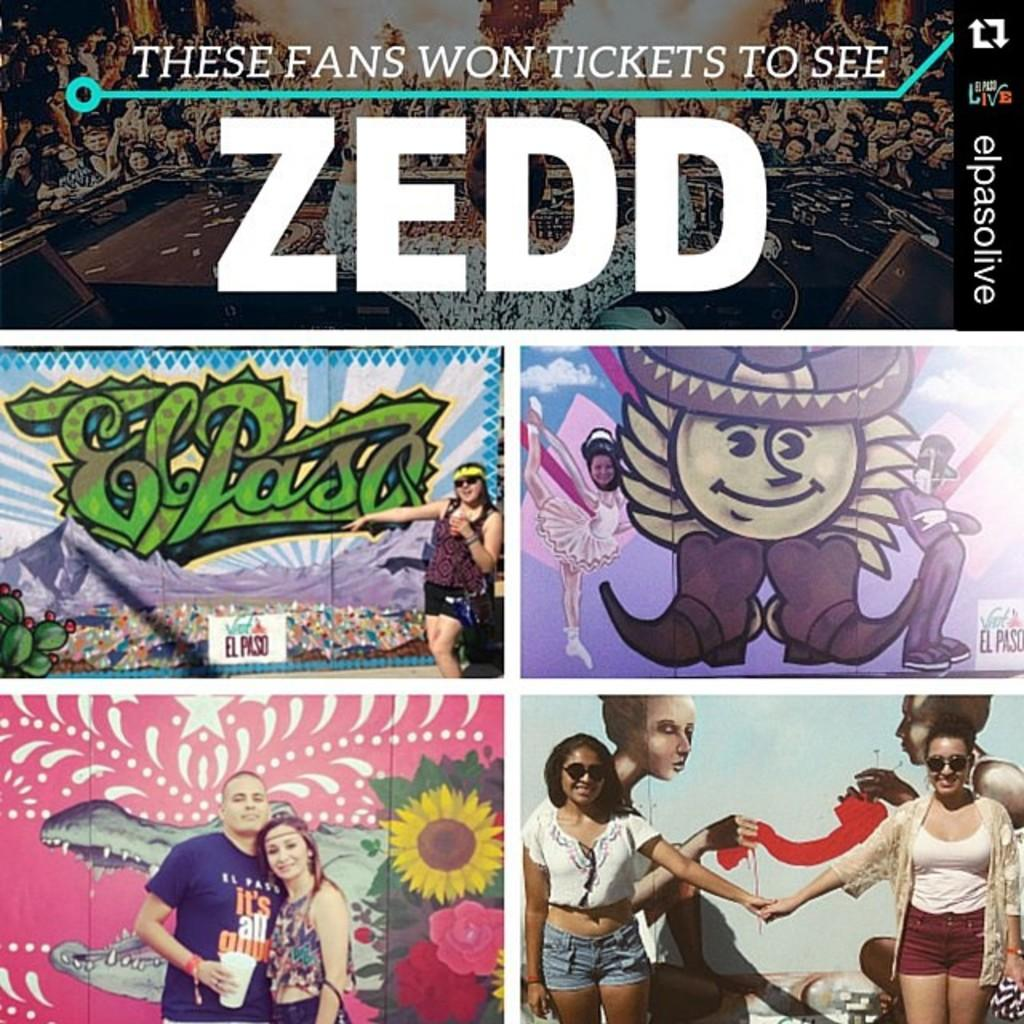<image>
Relay a brief, clear account of the picture shown. Graphic photos with individuals standing in front of a wall with El Paso on it. 